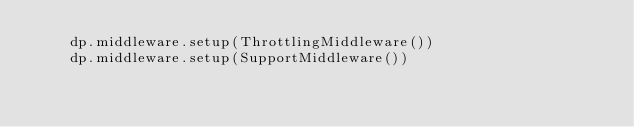<code> <loc_0><loc_0><loc_500><loc_500><_Python_>    dp.middleware.setup(ThrottlingMiddleware())
    dp.middleware.setup(SupportMiddleware())
</code> 